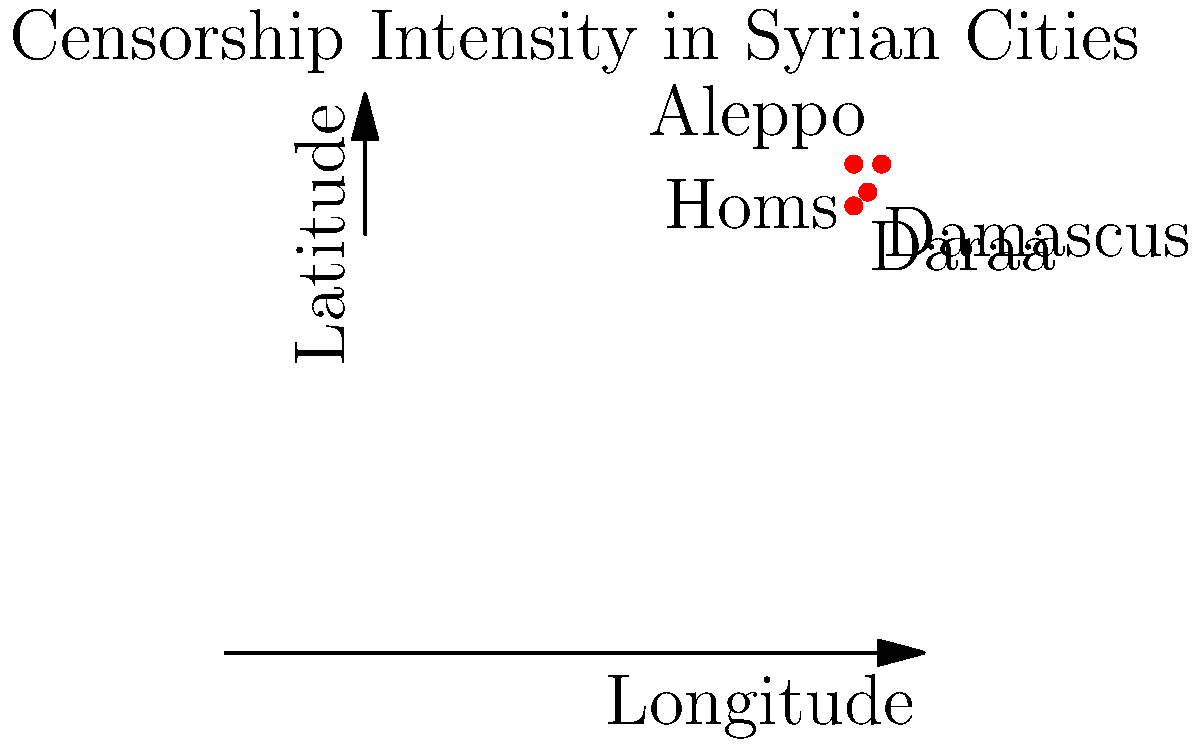Using the geographic coordinate system shown, which Syrian city experiencing censorship is located at approximately (37°E, 35°N)? To answer this question, we need to follow these steps:

1. Understand the coordinate system:
   - The x-axis represents longitude (East-West)
   - The y-axis represents latitude (North-South)

2. Identify the given coordinates:
   - Longitude: 37°E
   - Latitude: 35°N

3. Locate the point (37, 35) on the graph:
   - Move 37 units along the x-axis (longitude)
   - Move 35 units along the y-axis (latitude)

4. Observe which city is marked at or near this point:
   - We can see that Aleppo is located at approximately (37°E, 35°N)

5. Verify other cities' locations:
   - Damascus: (36°E, 33°N)
   - Homs: (35°E, 35°N)
   - Daraa: (35°E, 32°N)

Therefore, the Syrian city experiencing censorship located at approximately (37°E, 35°N) is Aleppo.
Answer: Aleppo 